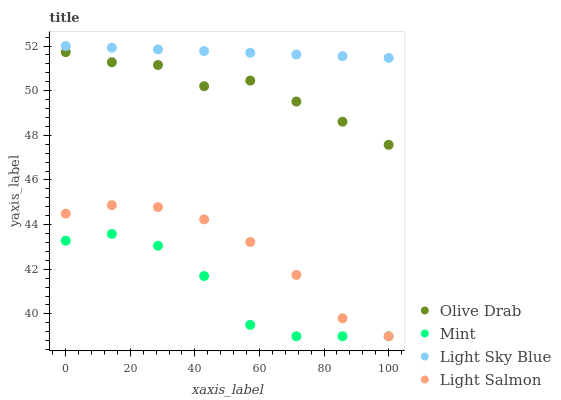Does Mint have the minimum area under the curve?
Answer yes or no. Yes. Does Light Sky Blue have the maximum area under the curve?
Answer yes or no. Yes. Does Light Sky Blue have the minimum area under the curve?
Answer yes or no. No. Does Mint have the maximum area under the curve?
Answer yes or no. No. Is Light Sky Blue the smoothest?
Answer yes or no. Yes. Is Mint the roughest?
Answer yes or no. Yes. Is Mint the smoothest?
Answer yes or no. No. Is Light Sky Blue the roughest?
Answer yes or no. No. Does Light Salmon have the lowest value?
Answer yes or no. Yes. Does Light Sky Blue have the lowest value?
Answer yes or no. No. Does Light Sky Blue have the highest value?
Answer yes or no. Yes. Does Mint have the highest value?
Answer yes or no. No. Is Mint less than Light Sky Blue?
Answer yes or no. Yes. Is Light Sky Blue greater than Light Salmon?
Answer yes or no. Yes. Does Mint intersect Light Salmon?
Answer yes or no. Yes. Is Mint less than Light Salmon?
Answer yes or no. No. Is Mint greater than Light Salmon?
Answer yes or no. No. Does Mint intersect Light Sky Blue?
Answer yes or no. No. 